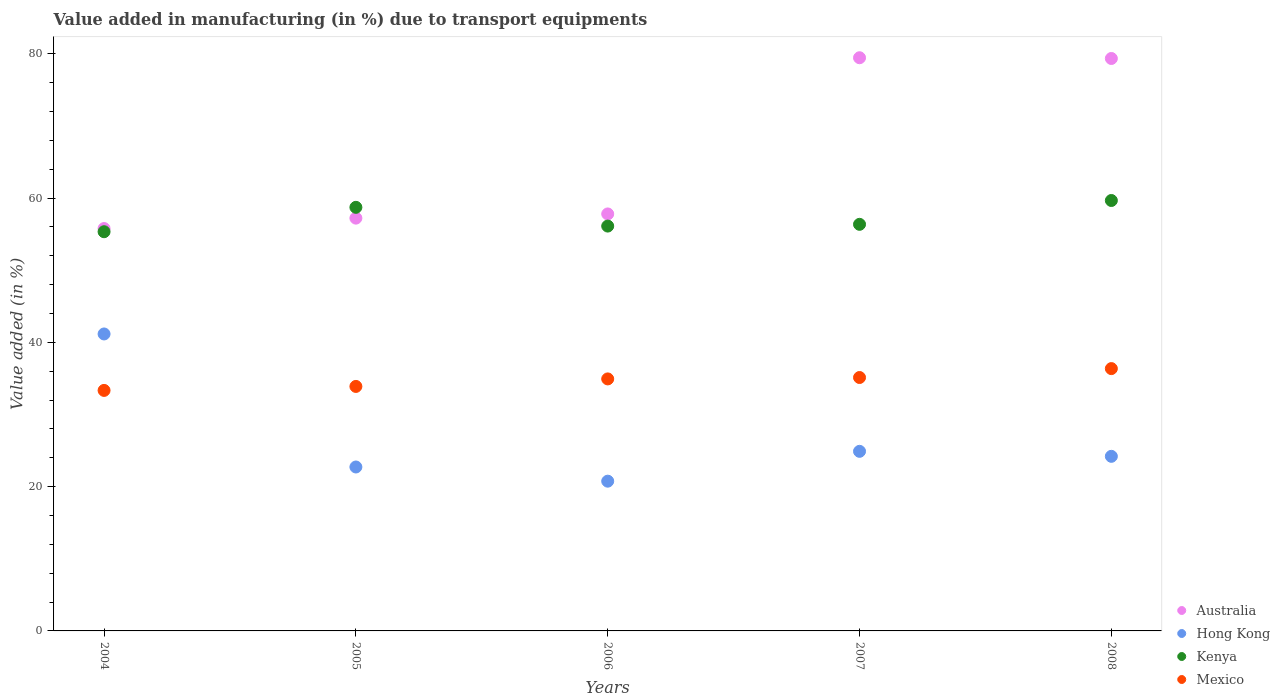How many different coloured dotlines are there?
Give a very brief answer. 4. What is the percentage of value added in manufacturing due to transport equipments in Australia in 2004?
Provide a short and direct response. 55.78. Across all years, what is the maximum percentage of value added in manufacturing due to transport equipments in Hong Kong?
Provide a short and direct response. 41.17. Across all years, what is the minimum percentage of value added in manufacturing due to transport equipments in Kenya?
Your response must be concise. 55.34. What is the total percentage of value added in manufacturing due to transport equipments in Kenya in the graph?
Provide a succinct answer. 286.22. What is the difference between the percentage of value added in manufacturing due to transport equipments in Kenya in 2005 and that in 2006?
Make the answer very short. 2.6. What is the difference between the percentage of value added in manufacturing due to transport equipments in Kenya in 2006 and the percentage of value added in manufacturing due to transport equipments in Mexico in 2004?
Ensure brevity in your answer.  22.78. What is the average percentage of value added in manufacturing due to transport equipments in Australia per year?
Provide a succinct answer. 65.93. In the year 2004, what is the difference between the percentage of value added in manufacturing due to transport equipments in Mexico and percentage of value added in manufacturing due to transport equipments in Kenya?
Provide a succinct answer. -22. In how many years, is the percentage of value added in manufacturing due to transport equipments in Australia greater than 20 %?
Your response must be concise. 5. What is the ratio of the percentage of value added in manufacturing due to transport equipments in Australia in 2004 to that in 2007?
Your response must be concise. 0.7. Is the difference between the percentage of value added in manufacturing due to transport equipments in Mexico in 2007 and 2008 greater than the difference between the percentage of value added in manufacturing due to transport equipments in Kenya in 2007 and 2008?
Offer a very short reply. Yes. What is the difference between the highest and the second highest percentage of value added in manufacturing due to transport equipments in Mexico?
Provide a short and direct response. 1.23. What is the difference between the highest and the lowest percentage of value added in manufacturing due to transport equipments in Kenya?
Offer a terse response. 4.33. In how many years, is the percentage of value added in manufacturing due to transport equipments in Hong Kong greater than the average percentage of value added in manufacturing due to transport equipments in Hong Kong taken over all years?
Your answer should be compact. 1. Is it the case that in every year, the sum of the percentage of value added in manufacturing due to transport equipments in Mexico and percentage of value added in manufacturing due to transport equipments in Hong Kong  is greater than the percentage of value added in manufacturing due to transport equipments in Australia?
Make the answer very short. No. Does the percentage of value added in manufacturing due to transport equipments in Hong Kong monotonically increase over the years?
Keep it short and to the point. No. What is the difference between two consecutive major ticks on the Y-axis?
Your answer should be compact. 20. Are the values on the major ticks of Y-axis written in scientific E-notation?
Make the answer very short. No. Does the graph contain any zero values?
Provide a succinct answer. No. Does the graph contain grids?
Ensure brevity in your answer.  No. Where does the legend appear in the graph?
Your response must be concise. Bottom right. What is the title of the graph?
Make the answer very short. Value added in manufacturing (in %) due to transport equipments. What is the label or title of the Y-axis?
Ensure brevity in your answer.  Value added (in %). What is the Value added (in %) in Australia in 2004?
Your answer should be very brief. 55.78. What is the Value added (in %) of Hong Kong in 2004?
Offer a terse response. 41.17. What is the Value added (in %) in Kenya in 2004?
Keep it short and to the point. 55.34. What is the Value added (in %) of Mexico in 2004?
Your answer should be very brief. 33.34. What is the Value added (in %) in Australia in 2005?
Make the answer very short. 57.22. What is the Value added (in %) in Hong Kong in 2005?
Provide a succinct answer. 22.73. What is the Value added (in %) of Kenya in 2005?
Provide a short and direct response. 58.72. What is the Value added (in %) in Mexico in 2005?
Make the answer very short. 33.89. What is the Value added (in %) of Australia in 2006?
Offer a terse response. 57.81. What is the Value added (in %) of Hong Kong in 2006?
Ensure brevity in your answer.  20.76. What is the Value added (in %) of Kenya in 2006?
Provide a short and direct response. 56.12. What is the Value added (in %) in Mexico in 2006?
Your response must be concise. 34.94. What is the Value added (in %) of Australia in 2007?
Ensure brevity in your answer.  79.46. What is the Value added (in %) in Hong Kong in 2007?
Give a very brief answer. 24.9. What is the Value added (in %) of Kenya in 2007?
Keep it short and to the point. 56.37. What is the Value added (in %) of Mexico in 2007?
Your answer should be compact. 35.13. What is the Value added (in %) of Australia in 2008?
Your answer should be compact. 79.36. What is the Value added (in %) in Hong Kong in 2008?
Keep it short and to the point. 24.2. What is the Value added (in %) of Kenya in 2008?
Keep it short and to the point. 59.67. What is the Value added (in %) of Mexico in 2008?
Ensure brevity in your answer.  36.36. Across all years, what is the maximum Value added (in %) of Australia?
Keep it short and to the point. 79.46. Across all years, what is the maximum Value added (in %) of Hong Kong?
Give a very brief answer. 41.17. Across all years, what is the maximum Value added (in %) of Kenya?
Offer a terse response. 59.67. Across all years, what is the maximum Value added (in %) in Mexico?
Keep it short and to the point. 36.36. Across all years, what is the minimum Value added (in %) in Australia?
Provide a short and direct response. 55.78. Across all years, what is the minimum Value added (in %) of Hong Kong?
Give a very brief answer. 20.76. Across all years, what is the minimum Value added (in %) in Kenya?
Give a very brief answer. 55.34. Across all years, what is the minimum Value added (in %) in Mexico?
Give a very brief answer. 33.34. What is the total Value added (in %) in Australia in the graph?
Your answer should be very brief. 329.63. What is the total Value added (in %) of Hong Kong in the graph?
Give a very brief answer. 133.75. What is the total Value added (in %) in Kenya in the graph?
Offer a very short reply. 286.22. What is the total Value added (in %) of Mexico in the graph?
Keep it short and to the point. 173.67. What is the difference between the Value added (in %) in Australia in 2004 and that in 2005?
Give a very brief answer. -1.44. What is the difference between the Value added (in %) of Hong Kong in 2004 and that in 2005?
Keep it short and to the point. 18.44. What is the difference between the Value added (in %) in Kenya in 2004 and that in 2005?
Make the answer very short. -3.38. What is the difference between the Value added (in %) of Mexico in 2004 and that in 2005?
Ensure brevity in your answer.  -0.55. What is the difference between the Value added (in %) of Australia in 2004 and that in 2006?
Make the answer very short. -2.03. What is the difference between the Value added (in %) in Hong Kong in 2004 and that in 2006?
Provide a succinct answer. 20.41. What is the difference between the Value added (in %) of Kenya in 2004 and that in 2006?
Make the answer very short. -0.78. What is the difference between the Value added (in %) of Mexico in 2004 and that in 2006?
Keep it short and to the point. -1.59. What is the difference between the Value added (in %) in Australia in 2004 and that in 2007?
Make the answer very short. -23.68. What is the difference between the Value added (in %) in Hong Kong in 2004 and that in 2007?
Your answer should be very brief. 16.27. What is the difference between the Value added (in %) in Kenya in 2004 and that in 2007?
Provide a short and direct response. -1.03. What is the difference between the Value added (in %) of Mexico in 2004 and that in 2007?
Your response must be concise. -1.79. What is the difference between the Value added (in %) of Australia in 2004 and that in 2008?
Provide a succinct answer. -23.58. What is the difference between the Value added (in %) in Hong Kong in 2004 and that in 2008?
Provide a short and direct response. 16.96. What is the difference between the Value added (in %) in Kenya in 2004 and that in 2008?
Your answer should be very brief. -4.33. What is the difference between the Value added (in %) of Mexico in 2004 and that in 2008?
Your answer should be compact. -3.02. What is the difference between the Value added (in %) of Australia in 2005 and that in 2006?
Provide a succinct answer. -0.58. What is the difference between the Value added (in %) of Hong Kong in 2005 and that in 2006?
Give a very brief answer. 1.97. What is the difference between the Value added (in %) of Kenya in 2005 and that in 2006?
Offer a very short reply. 2.6. What is the difference between the Value added (in %) of Mexico in 2005 and that in 2006?
Offer a very short reply. -1.04. What is the difference between the Value added (in %) in Australia in 2005 and that in 2007?
Provide a short and direct response. -22.23. What is the difference between the Value added (in %) of Hong Kong in 2005 and that in 2007?
Give a very brief answer. -2.17. What is the difference between the Value added (in %) of Kenya in 2005 and that in 2007?
Offer a very short reply. 2.36. What is the difference between the Value added (in %) in Mexico in 2005 and that in 2007?
Make the answer very short. -1.24. What is the difference between the Value added (in %) of Australia in 2005 and that in 2008?
Ensure brevity in your answer.  -22.13. What is the difference between the Value added (in %) of Hong Kong in 2005 and that in 2008?
Your response must be concise. -1.48. What is the difference between the Value added (in %) of Kenya in 2005 and that in 2008?
Your answer should be compact. -0.95. What is the difference between the Value added (in %) of Mexico in 2005 and that in 2008?
Offer a very short reply. -2.47. What is the difference between the Value added (in %) in Australia in 2006 and that in 2007?
Your answer should be compact. -21.65. What is the difference between the Value added (in %) of Hong Kong in 2006 and that in 2007?
Your response must be concise. -4.14. What is the difference between the Value added (in %) of Kenya in 2006 and that in 2007?
Offer a very short reply. -0.24. What is the difference between the Value added (in %) in Mexico in 2006 and that in 2007?
Make the answer very short. -0.2. What is the difference between the Value added (in %) in Australia in 2006 and that in 2008?
Provide a short and direct response. -21.55. What is the difference between the Value added (in %) in Hong Kong in 2006 and that in 2008?
Provide a succinct answer. -3.44. What is the difference between the Value added (in %) of Kenya in 2006 and that in 2008?
Your response must be concise. -3.55. What is the difference between the Value added (in %) of Mexico in 2006 and that in 2008?
Offer a very short reply. -1.43. What is the difference between the Value added (in %) of Australia in 2007 and that in 2008?
Offer a very short reply. 0.1. What is the difference between the Value added (in %) of Hong Kong in 2007 and that in 2008?
Make the answer very short. 0.69. What is the difference between the Value added (in %) in Kenya in 2007 and that in 2008?
Provide a succinct answer. -3.3. What is the difference between the Value added (in %) of Mexico in 2007 and that in 2008?
Offer a terse response. -1.23. What is the difference between the Value added (in %) in Australia in 2004 and the Value added (in %) in Hong Kong in 2005?
Keep it short and to the point. 33.06. What is the difference between the Value added (in %) of Australia in 2004 and the Value added (in %) of Kenya in 2005?
Provide a succinct answer. -2.94. What is the difference between the Value added (in %) of Australia in 2004 and the Value added (in %) of Mexico in 2005?
Your answer should be compact. 21.89. What is the difference between the Value added (in %) in Hong Kong in 2004 and the Value added (in %) in Kenya in 2005?
Your answer should be compact. -17.55. What is the difference between the Value added (in %) in Hong Kong in 2004 and the Value added (in %) in Mexico in 2005?
Make the answer very short. 7.27. What is the difference between the Value added (in %) of Kenya in 2004 and the Value added (in %) of Mexico in 2005?
Your response must be concise. 21.45. What is the difference between the Value added (in %) in Australia in 2004 and the Value added (in %) in Hong Kong in 2006?
Offer a terse response. 35.02. What is the difference between the Value added (in %) of Australia in 2004 and the Value added (in %) of Kenya in 2006?
Offer a very short reply. -0.34. What is the difference between the Value added (in %) of Australia in 2004 and the Value added (in %) of Mexico in 2006?
Your response must be concise. 20.85. What is the difference between the Value added (in %) of Hong Kong in 2004 and the Value added (in %) of Kenya in 2006?
Provide a succinct answer. -14.96. What is the difference between the Value added (in %) in Hong Kong in 2004 and the Value added (in %) in Mexico in 2006?
Ensure brevity in your answer.  6.23. What is the difference between the Value added (in %) in Kenya in 2004 and the Value added (in %) in Mexico in 2006?
Your answer should be very brief. 20.4. What is the difference between the Value added (in %) in Australia in 2004 and the Value added (in %) in Hong Kong in 2007?
Your response must be concise. 30.88. What is the difference between the Value added (in %) of Australia in 2004 and the Value added (in %) of Kenya in 2007?
Your answer should be very brief. -0.58. What is the difference between the Value added (in %) in Australia in 2004 and the Value added (in %) in Mexico in 2007?
Provide a succinct answer. 20.65. What is the difference between the Value added (in %) in Hong Kong in 2004 and the Value added (in %) in Kenya in 2007?
Offer a very short reply. -15.2. What is the difference between the Value added (in %) in Hong Kong in 2004 and the Value added (in %) in Mexico in 2007?
Ensure brevity in your answer.  6.04. What is the difference between the Value added (in %) of Kenya in 2004 and the Value added (in %) of Mexico in 2007?
Offer a terse response. 20.21. What is the difference between the Value added (in %) of Australia in 2004 and the Value added (in %) of Hong Kong in 2008?
Your response must be concise. 31.58. What is the difference between the Value added (in %) of Australia in 2004 and the Value added (in %) of Kenya in 2008?
Ensure brevity in your answer.  -3.89. What is the difference between the Value added (in %) of Australia in 2004 and the Value added (in %) of Mexico in 2008?
Make the answer very short. 19.42. What is the difference between the Value added (in %) in Hong Kong in 2004 and the Value added (in %) in Kenya in 2008?
Offer a terse response. -18.5. What is the difference between the Value added (in %) of Hong Kong in 2004 and the Value added (in %) of Mexico in 2008?
Keep it short and to the point. 4.8. What is the difference between the Value added (in %) of Kenya in 2004 and the Value added (in %) of Mexico in 2008?
Your answer should be very brief. 18.98. What is the difference between the Value added (in %) of Australia in 2005 and the Value added (in %) of Hong Kong in 2006?
Your answer should be very brief. 36.47. What is the difference between the Value added (in %) of Australia in 2005 and the Value added (in %) of Kenya in 2006?
Ensure brevity in your answer.  1.1. What is the difference between the Value added (in %) in Australia in 2005 and the Value added (in %) in Mexico in 2006?
Make the answer very short. 22.29. What is the difference between the Value added (in %) of Hong Kong in 2005 and the Value added (in %) of Kenya in 2006?
Keep it short and to the point. -33.4. What is the difference between the Value added (in %) in Hong Kong in 2005 and the Value added (in %) in Mexico in 2006?
Give a very brief answer. -12.21. What is the difference between the Value added (in %) in Kenya in 2005 and the Value added (in %) in Mexico in 2006?
Provide a short and direct response. 23.79. What is the difference between the Value added (in %) of Australia in 2005 and the Value added (in %) of Hong Kong in 2007?
Your answer should be compact. 32.33. What is the difference between the Value added (in %) of Australia in 2005 and the Value added (in %) of Kenya in 2007?
Your response must be concise. 0.86. What is the difference between the Value added (in %) in Australia in 2005 and the Value added (in %) in Mexico in 2007?
Offer a very short reply. 22.09. What is the difference between the Value added (in %) in Hong Kong in 2005 and the Value added (in %) in Kenya in 2007?
Your answer should be compact. -33.64. What is the difference between the Value added (in %) of Hong Kong in 2005 and the Value added (in %) of Mexico in 2007?
Make the answer very short. -12.41. What is the difference between the Value added (in %) in Kenya in 2005 and the Value added (in %) in Mexico in 2007?
Offer a terse response. 23.59. What is the difference between the Value added (in %) in Australia in 2005 and the Value added (in %) in Hong Kong in 2008?
Offer a terse response. 33.02. What is the difference between the Value added (in %) in Australia in 2005 and the Value added (in %) in Kenya in 2008?
Your answer should be very brief. -2.44. What is the difference between the Value added (in %) of Australia in 2005 and the Value added (in %) of Mexico in 2008?
Give a very brief answer. 20.86. What is the difference between the Value added (in %) in Hong Kong in 2005 and the Value added (in %) in Kenya in 2008?
Provide a short and direct response. -36.94. What is the difference between the Value added (in %) of Hong Kong in 2005 and the Value added (in %) of Mexico in 2008?
Provide a short and direct response. -13.64. What is the difference between the Value added (in %) of Kenya in 2005 and the Value added (in %) of Mexico in 2008?
Your answer should be compact. 22.36. What is the difference between the Value added (in %) in Australia in 2006 and the Value added (in %) in Hong Kong in 2007?
Keep it short and to the point. 32.91. What is the difference between the Value added (in %) in Australia in 2006 and the Value added (in %) in Kenya in 2007?
Ensure brevity in your answer.  1.44. What is the difference between the Value added (in %) of Australia in 2006 and the Value added (in %) of Mexico in 2007?
Make the answer very short. 22.68. What is the difference between the Value added (in %) in Hong Kong in 2006 and the Value added (in %) in Kenya in 2007?
Provide a succinct answer. -35.61. What is the difference between the Value added (in %) in Hong Kong in 2006 and the Value added (in %) in Mexico in 2007?
Offer a terse response. -14.37. What is the difference between the Value added (in %) of Kenya in 2006 and the Value added (in %) of Mexico in 2007?
Keep it short and to the point. 20.99. What is the difference between the Value added (in %) in Australia in 2006 and the Value added (in %) in Hong Kong in 2008?
Ensure brevity in your answer.  33.6. What is the difference between the Value added (in %) in Australia in 2006 and the Value added (in %) in Kenya in 2008?
Provide a short and direct response. -1.86. What is the difference between the Value added (in %) of Australia in 2006 and the Value added (in %) of Mexico in 2008?
Your answer should be compact. 21.44. What is the difference between the Value added (in %) of Hong Kong in 2006 and the Value added (in %) of Kenya in 2008?
Give a very brief answer. -38.91. What is the difference between the Value added (in %) in Hong Kong in 2006 and the Value added (in %) in Mexico in 2008?
Make the answer very short. -15.6. What is the difference between the Value added (in %) in Kenya in 2006 and the Value added (in %) in Mexico in 2008?
Make the answer very short. 19.76. What is the difference between the Value added (in %) of Australia in 2007 and the Value added (in %) of Hong Kong in 2008?
Your answer should be very brief. 55.26. What is the difference between the Value added (in %) in Australia in 2007 and the Value added (in %) in Kenya in 2008?
Make the answer very short. 19.79. What is the difference between the Value added (in %) in Australia in 2007 and the Value added (in %) in Mexico in 2008?
Your response must be concise. 43.09. What is the difference between the Value added (in %) in Hong Kong in 2007 and the Value added (in %) in Kenya in 2008?
Provide a short and direct response. -34.77. What is the difference between the Value added (in %) in Hong Kong in 2007 and the Value added (in %) in Mexico in 2008?
Your response must be concise. -11.47. What is the difference between the Value added (in %) in Kenya in 2007 and the Value added (in %) in Mexico in 2008?
Give a very brief answer. 20. What is the average Value added (in %) in Australia per year?
Ensure brevity in your answer.  65.93. What is the average Value added (in %) in Hong Kong per year?
Your answer should be compact. 26.75. What is the average Value added (in %) in Kenya per year?
Your response must be concise. 57.24. What is the average Value added (in %) in Mexico per year?
Your answer should be compact. 34.73. In the year 2004, what is the difference between the Value added (in %) of Australia and Value added (in %) of Hong Kong?
Keep it short and to the point. 14.61. In the year 2004, what is the difference between the Value added (in %) of Australia and Value added (in %) of Kenya?
Provide a succinct answer. 0.44. In the year 2004, what is the difference between the Value added (in %) in Australia and Value added (in %) in Mexico?
Your answer should be very brief. 22.44. In the year 2004, what is the difference between the Value added (in %) in Hong Kong and Value added (in %) in Kenya?
Offer a terse response. -14.17. In the year 2004, what is the difference between the Value added (in %) in Hong Kong and Value added (in %) in Mexico?
Provide a short and direct response. 7.82. In the year 2004, what is the difference between the Value added (in %) in Kenya and Value added (in %) in Mexico?
Your answer should be very brief. 22. In the year 2005, what is the difference between the Value added (in %) of Australia and Value added (in %) of Hong Kong?
Provide a succinct answer. 34.5. In the year 2005, what is the difference between the Value added (in %) in Australia and Value added (in %) in Kenya?
Ensure brevity in your answer.  -1.5. In the year 2005, what is the difference between the Value added (in %) of Australia and Value added (in %) of Mexico?
Your response must be concise. 23.33. In the year 2005, what is the difference between the Value added (in %) in Hong Kong and Value added (in %) in Kenya?
Provide a succinct answer. -36. In the year 2005, what is the difference between the Value added (in %) in Hong Kong and Value added (in %) in Mexico?
Provide a short and direct response. -11.17. In the year 2005, what is the difference between the Value added (in %) of Kenya and Value added (in %) of Mexico?
Your response must be concise. 24.83. In the year 2006, what is the difference between the Value added (in %) in Australia and Value added (in %) in Hong Kong?
Ensure brevity in your answer.  37.05. In the year 2006, what is the difference between the Value added (in %) of Australia and Value added (in %) of Kenya?
Offer a terse response. 1.68. In the year 2006, what is the difference between the Value added (in %) in Australia and Value added (in %) in Mexico?
Your answer should be compact. 22.87. In the year 2006, what is the difference between the Value added (in %) in Hong Kong and Value added (in %) in Kenya?
Make the answer very short. -35.36. In the year 2006, what is the difference between the Value added (in %) of Hong Kong and Value added (in %) of Mexico?
Make the answer very short. -14.18. In the year 2006, what is the difference between the Value added (in %) in Kenya and Value added (in %) in Mexico?
Make the answer very short. 21.19. In the year 2007, what is the difference between the Value added (in %) of Australia and Value added (in %) of Hong Kong?
Offer a very short reply. 54.56. In the year 2007, what is the difference between the Value added (in %) of Australia and Value added (in %) of Kenya?
Provide a succinct answer. 23.09. In the year 2007, what is the difference between the Value added (in %) in Australia and Value added (in %) in Mexico?
Provide a short and direct response. 44.33. In the year 2007, what is the difference between the Value added (in %) of Hong Kong and Value added (in %) of Kenya?
Offer a terse response. -31.47. In the year 2007, what is the difference between the Value added (in %) of Hong Kong and Value added (in %) of Mexico?
Make the answer very short. -10.23. In the year 2007, what is the difference between the Value added (in %) in Kenya and Value added (in %) in Mexico?
Offer a very short reply. 21.23. In the year 2008, what is the difference between the Value added (in %) of Australia and Value added (in %) of Hong Kong?
Provide a succinct answer. 55.15. In the year 2008, what is the difference between the Value added (in %) in Australia and Value added (in %) in Kenya?
Keep it short and to the point. 19.69. In the year 2008, what is the difference between the Value added (in %) in Australia and Value added (in %) in Mexico?
Your answer should be compact. 42.99. In the year 2008, what is the difference between the Value added (in %) of Hong Kong and Value added (in %) of Kenya?
Offer a terse response. -35.47. In the year 2008, what is the difference between the Value added (in %) of Hong Kong and Value added (in %) of Mexico?
Make the answer very short. -12.16. In the year 2008, what is the difference between the Value added (in %) in Kenya and Value added (in %) in Mexico?
Give a very brief answer. 23.3. What is the ratio of the Value added (in %) of Australia in 2004 to that in 2005?
Your answer should be compact. 0.97. What is the ratio of the Value added (in %) in Hong Kong in 2004 to that in 2005?
Offer a terse response. 1.81. What is the ratio of the Value added (in %) of Kenya in 2004 to that in 2005?
Offer a very short reply. 0.94. What is the ratio of the Value added (in %) in Mexico in 2004 to that in 2005?
Provide a succinct answer. 0.98. What is the ratio of the Value added (in %) of Hong Kong in 2004 to that in 2006?
Your response must be concise. 1.98. What is the ratio of the Value added (in %) of Kenya in 2004 to that in 2006?
Your answer should be compact. 0.99. What is the ratio of the Value added (in %) in Mexico in 2004 to that in 2006?
Your answer should be very brief. 0.95. What is the ratio of the Value added (in %) of Australia in 2004 to that in 2007?
Your response must be concise. 0.7. What is the ratio of the Value added (in %) in Hong Kong in 2004 to that in 2007?
Provide a succinct answer. 1.65. What is the ratio of the Value added (in %) of Kenya in 2004 to that in 2007?
Keep it short and to the point. 0.98. What is the ratio of the Value added (in %) in Mexico in 2004 to that in 2007?
Provide a short and direct response. 0.95. What is the ratio of the Value added (in %) of Australia in 2004 to that in 2008?
Your answer should be very brief. 0.7. What is the ratio of the Value added (in %) of Hong Kong in 2004 to that in 2008?
Provide a succinct answer. 1.7. What is the ratio of the Value added (in %) of Kenya in 2004 to that in 2008?
Provide a short and direct response. 0.93. What is the ratio of the Value added (in %) in Mexico in 2004 to that in 2008?
Keep it short and to the point. 0.92. What is the ratio of the Value added (in %) in Hong Kong in 2005 to that in 2006?
Your answer should be very brief. 1.09. What is the ratio of the Value added (in %) in Kenya in 2005 to that in 2006?
Make the answer very short. 1.05. What is the ratio of the Value added (in %) in Mexico in 2005 to that in 2006?
Offer a very short reply. 0.97. What is the ratio of the Value added (in %) of Australia in 2005 to that in 2007?
Give a very brief answer. 0.72. What is the ratio of the Value added (in %) in Hong Kong in 2005 to that in 2007?
Ensure brevity in your answer.  0.91. What is the ratio of the Value added (in %) in Kenya in 2005 to that in 2007?
Give a very brief answer. 1.04. What is the ratio of the Value added (in %) in Mexico in 2005 to that in 2007?
Provide a short and direct response. 0.96. What is the ratio of the Value added (in %) in Australia in 2005 to that in 2008?
Your answer should be very brief. 0.72. What is the ratio of the Value added (in %) in Hong Kong in 2005 to that in 2008?
Ensure brevity in your answer.  0.94. What is the ratio of the Value added (in %) in Kenya in 2005 to that in 2008?
Ensure brevity in your answer.  0.98. What is the ratio of the Value added (in %) in Mexico in 2005 to that in 2008?
Offer a very short reply. 0.93. What is the ratio of the Value added (in %) in Australia in 2006 to that in 2007?
Your response must be concise. 0.73. What is the ratio of the Value added (in %) in Hong Kong in 2006 to that in 2007?
Your answer should be very brief. 0.83. What is the ratio of the Value added (in %) of Kenya in 2006 to that in 2007?
Ensure brevity in your answer.  1. What is the ratio of the Value added (in %) of Australia in 2006 to that in 2008?
Make the answer very short. 0.73. What is the ratio of the Value added (in %) in Hong Kong in 2006 to that in 2008?
Give a very brief answer. 0.86. What is the ratio of the Value added (in %) of Kenya in 2006 to that in 2008?
Ensure brevity in your answer.  0.94. What is the ratio of the Value added (in %) in Mexico in 2006 to that in 2008?
Your answer should be very brief. 0.96. What is the ratio of the Value added (in %) of Hong Kong in 2007 to that in 2008?
Provide a succinct answer. 1.03. What is the ratio of the Value added (in %) in Kenya in 2007 to that in 2008?
Provide a succinct answer. 0.94. What is the ratio of the Value added (in %) in Mexico in 2007 to that in 2008?
Provide a succinct answer. 0.97. What is the difference between the highest and the second highest Value added (in %) of Australia?
Provide a succinct answer. 0.1. What is the difference between the highest and the second highest Value added (in %) in Hong Kong?
Keep it short and to the point. 16.27. What is the difference between the highest and the second highest Value added (in %) of Kenya?
Offer a terse response. 0.95. What is the difference between the highest and the second highest Value added (in %) of Mexico?
Keep it short and to the point. 1.23. What is the difference between the highest and the lowest Value added (in %) of Australia?
Make the answer very short. 23.68. What is the difference between the highest and the lowest Value added (in %) of Hong Kong?
Ensure brevity in your answer.  20.41. What is the difference between the highest and the lowest Value added (in %) in Kenya?
Your answer should be very brief. 4.33. What is the difference between the highest and the lowest Value added (in %) in Mexico?
Your answer should be very brief. 3.02. 